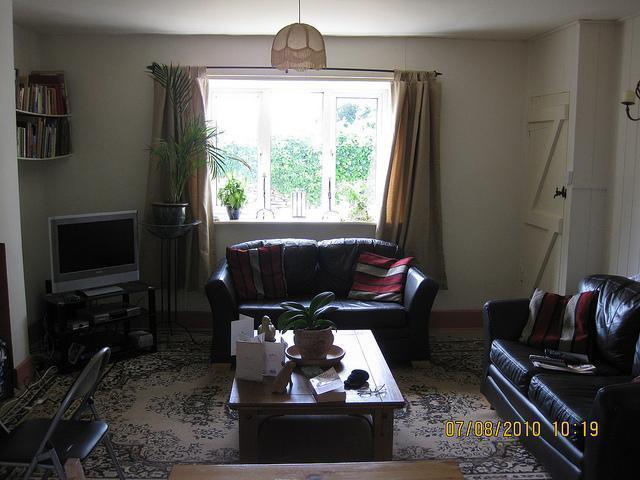What type of plant is on the coffee table?
Make your selection and explain in format: 'Answer: answer
Rationale: rationale.'
Options: Begonia, orchid, violet, fern. Answer: orchid.
Rationale: Orchids are big, green, and flat. 